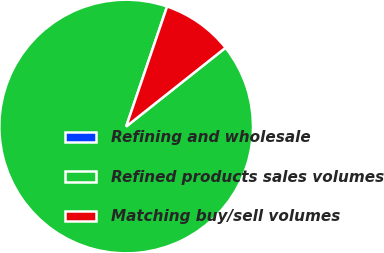Convert chart to OTSL. <chart><loc_0><loc_0><loc_500><loc_500><pie_chart><fcel>Refining and wholesale<fcel>Refined products sales volumes<fcel>Matching buy/sell volumes<nl><fcel>0.01%<fcel>90.89%<fcel>9.1%<nl></chart> 